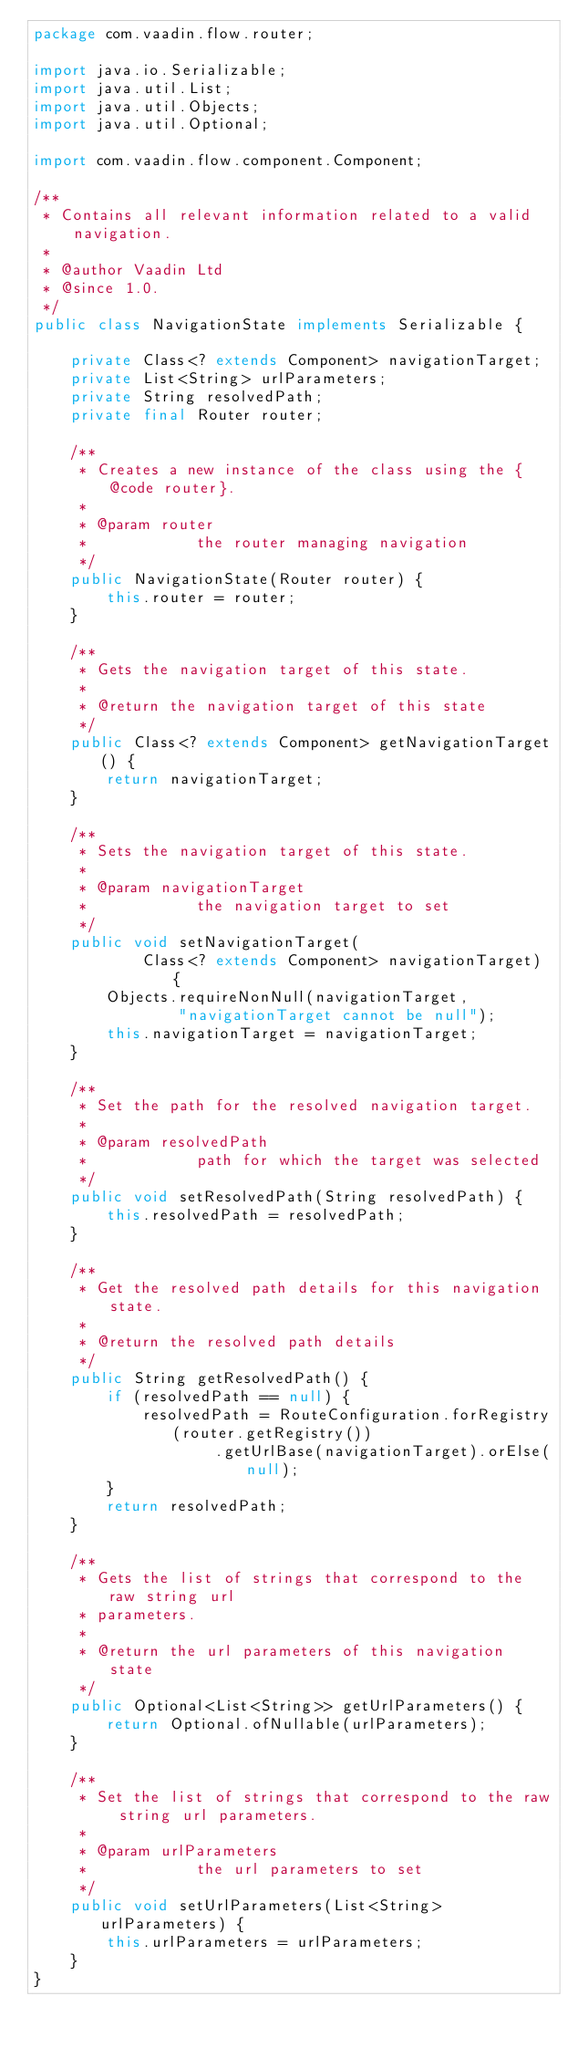<code> <loc_0><loc_0><loc_500><loc_500><_Java_>package com.vaadin.flow.router;

import java.io.Serializable;
import java.util.List;
import java.util.Objects;
import java.util.Optional;

import com.vaadin.flow.component.Component;

/**
 * Contains all relevant information related to a valid navigation.
 *
 * @author Vaadin Ltd
 * @since 1.0.
 */
public class NavigationState implements Serializable {

    private Class<? extends Component> navigationTarget;
    private List<String> urlParameters;
    private String resolvedPath;
    private final Router router;

    /**
     * Creates a new instance of the class using the {@code router}.
     *
     * @param router
     *            the router managing navigation
     */
    public NavigationState(Router router) {
        this.router = router;
    }

    /**
     * Gets the navigation target of this state.
     *
     * @return the navigation target of this state
     */
    public Class<? extends Component> getNavigationTarget() {
        return navigationTarget;
    }

    /**
     * Sets the navigation target of this state.
     *
     * @param navigationTarget
     *            the navigation target to set
     */
    public void setNavigationTarget(
            Class<? extends Component> navigationTarget) {
        Objects.requireNonNull(navigationTarget,
                "navigationTarget cannot be null");
        this.navigationTarget = navigationTarget;
    }

    /**
     * Set the path for the resolved navigation target.
     *
     * @param resolvedPath
     *            path for which the target was selected
     */
    public void setResolvedPath(String resolvedPath) {
        this.resolvedPath = resolvedPath;
    }

    /**
     * Get the resolved path details for this navigation state.
     *
     * @return the resolved path details
     */
    public String getResolvedPath() {
        if (resolvedPath == null) {
            resolvedPath = RouteConfiguration.forRegistry(router.getRegistry())
                    .getUrlBase(navigationTarget).orElse(null);
        }
        return resolvedPath;
    }

    /**
     * Gets the list of strings that correspond to the raw string url
     * parameters.
     *
     * @return the url parameters of this navigation state
     */
    public Optional<List<String>> getUrlParameters() {
        return Optional.ofNullable(urlParameters);
    }

    /**
     * Set the list of strings that correspond to the raw string url parameters.
     *
     * @param urlParameters
     *            the url parameters to set
     */
    public void setUrlParameters(List<String> urlParameters) {
        this.urlParameters = urlParameters;
    }
}
</code> 